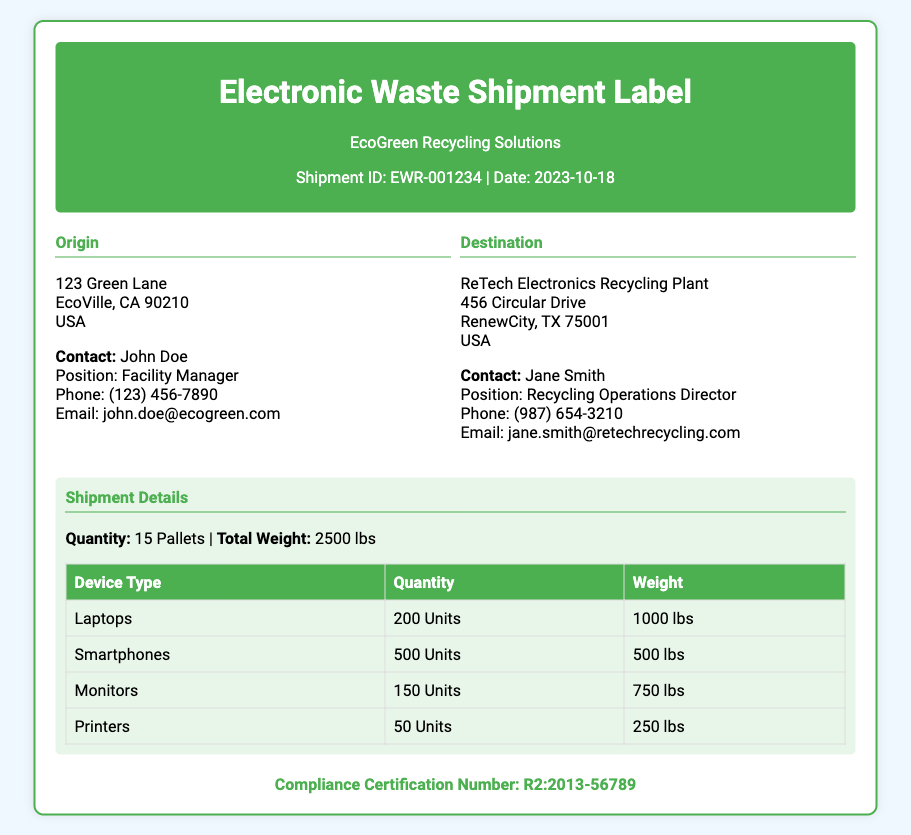what is the shipment ID? The shipment ID is provided under the header, specifically labeled as "Shipment ID".
Answer: EWR-001234 who is the contact person at the recycling facility? The contact person is listed under the Origin section, detailing their name and position.
Answer: John Doe what is the total weight of the shipment? The total weight is mentioned in the Shipment Details section.
Answer: 2500 lbs how many laptops are included in this shipment? The number of laptops is specified in the shipment details table.
Answer: 200 Units what is the Compliance Certification Number? The compliance certification number is provided at the bottom of the document.
Answer: R2:2013-56789 what is the destination of the shipment? The destination is listed in the Destination section of the document.
Answer: ReTech Electronics Recycling Plant how many total pallets are included in the shipment? The total number of pallets is indicated in the Shipment Details section.
Answer: 15 Pallets which device type has the highest quantity? The device type with the highest quantity is determined from the shipment details table.
Answer: Smartphones what is the contact email for the recycling operations director? The contact email is listed under the Destination section for the recycling operations director.
Answer: jane.smith@retechrecycling.com 